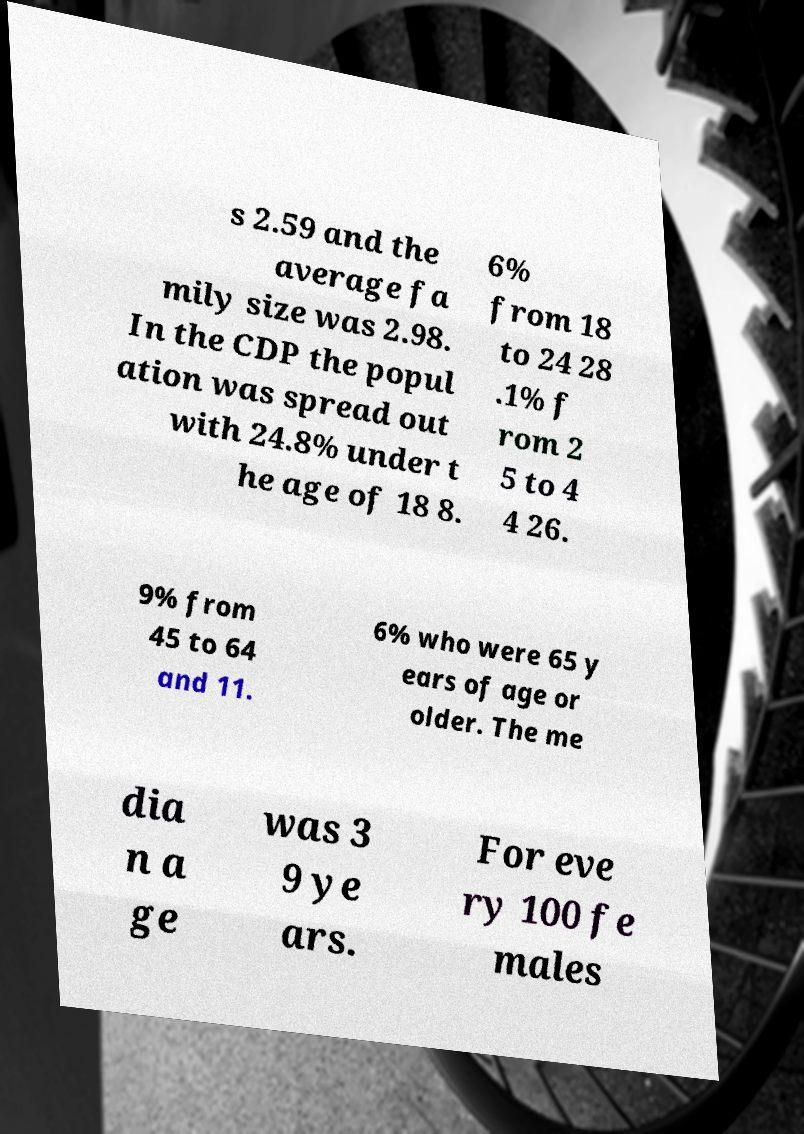There's text embedded in this image that I need extracted. Can you transcribe it verbatim? s 2.59 and the average fa mily size was 2.98. In the CDP the popul ation was spread out with 24.8% under t he age of 18 8. 6% from 18 to 24 28 .1% f rom 2 5 to 4 4 26. 9% from 45 to 64 and 11. 6% who were 65 y ears of age or older. The me dia n a ge was 3 9 ye ars. For eve ry 100 fe males 